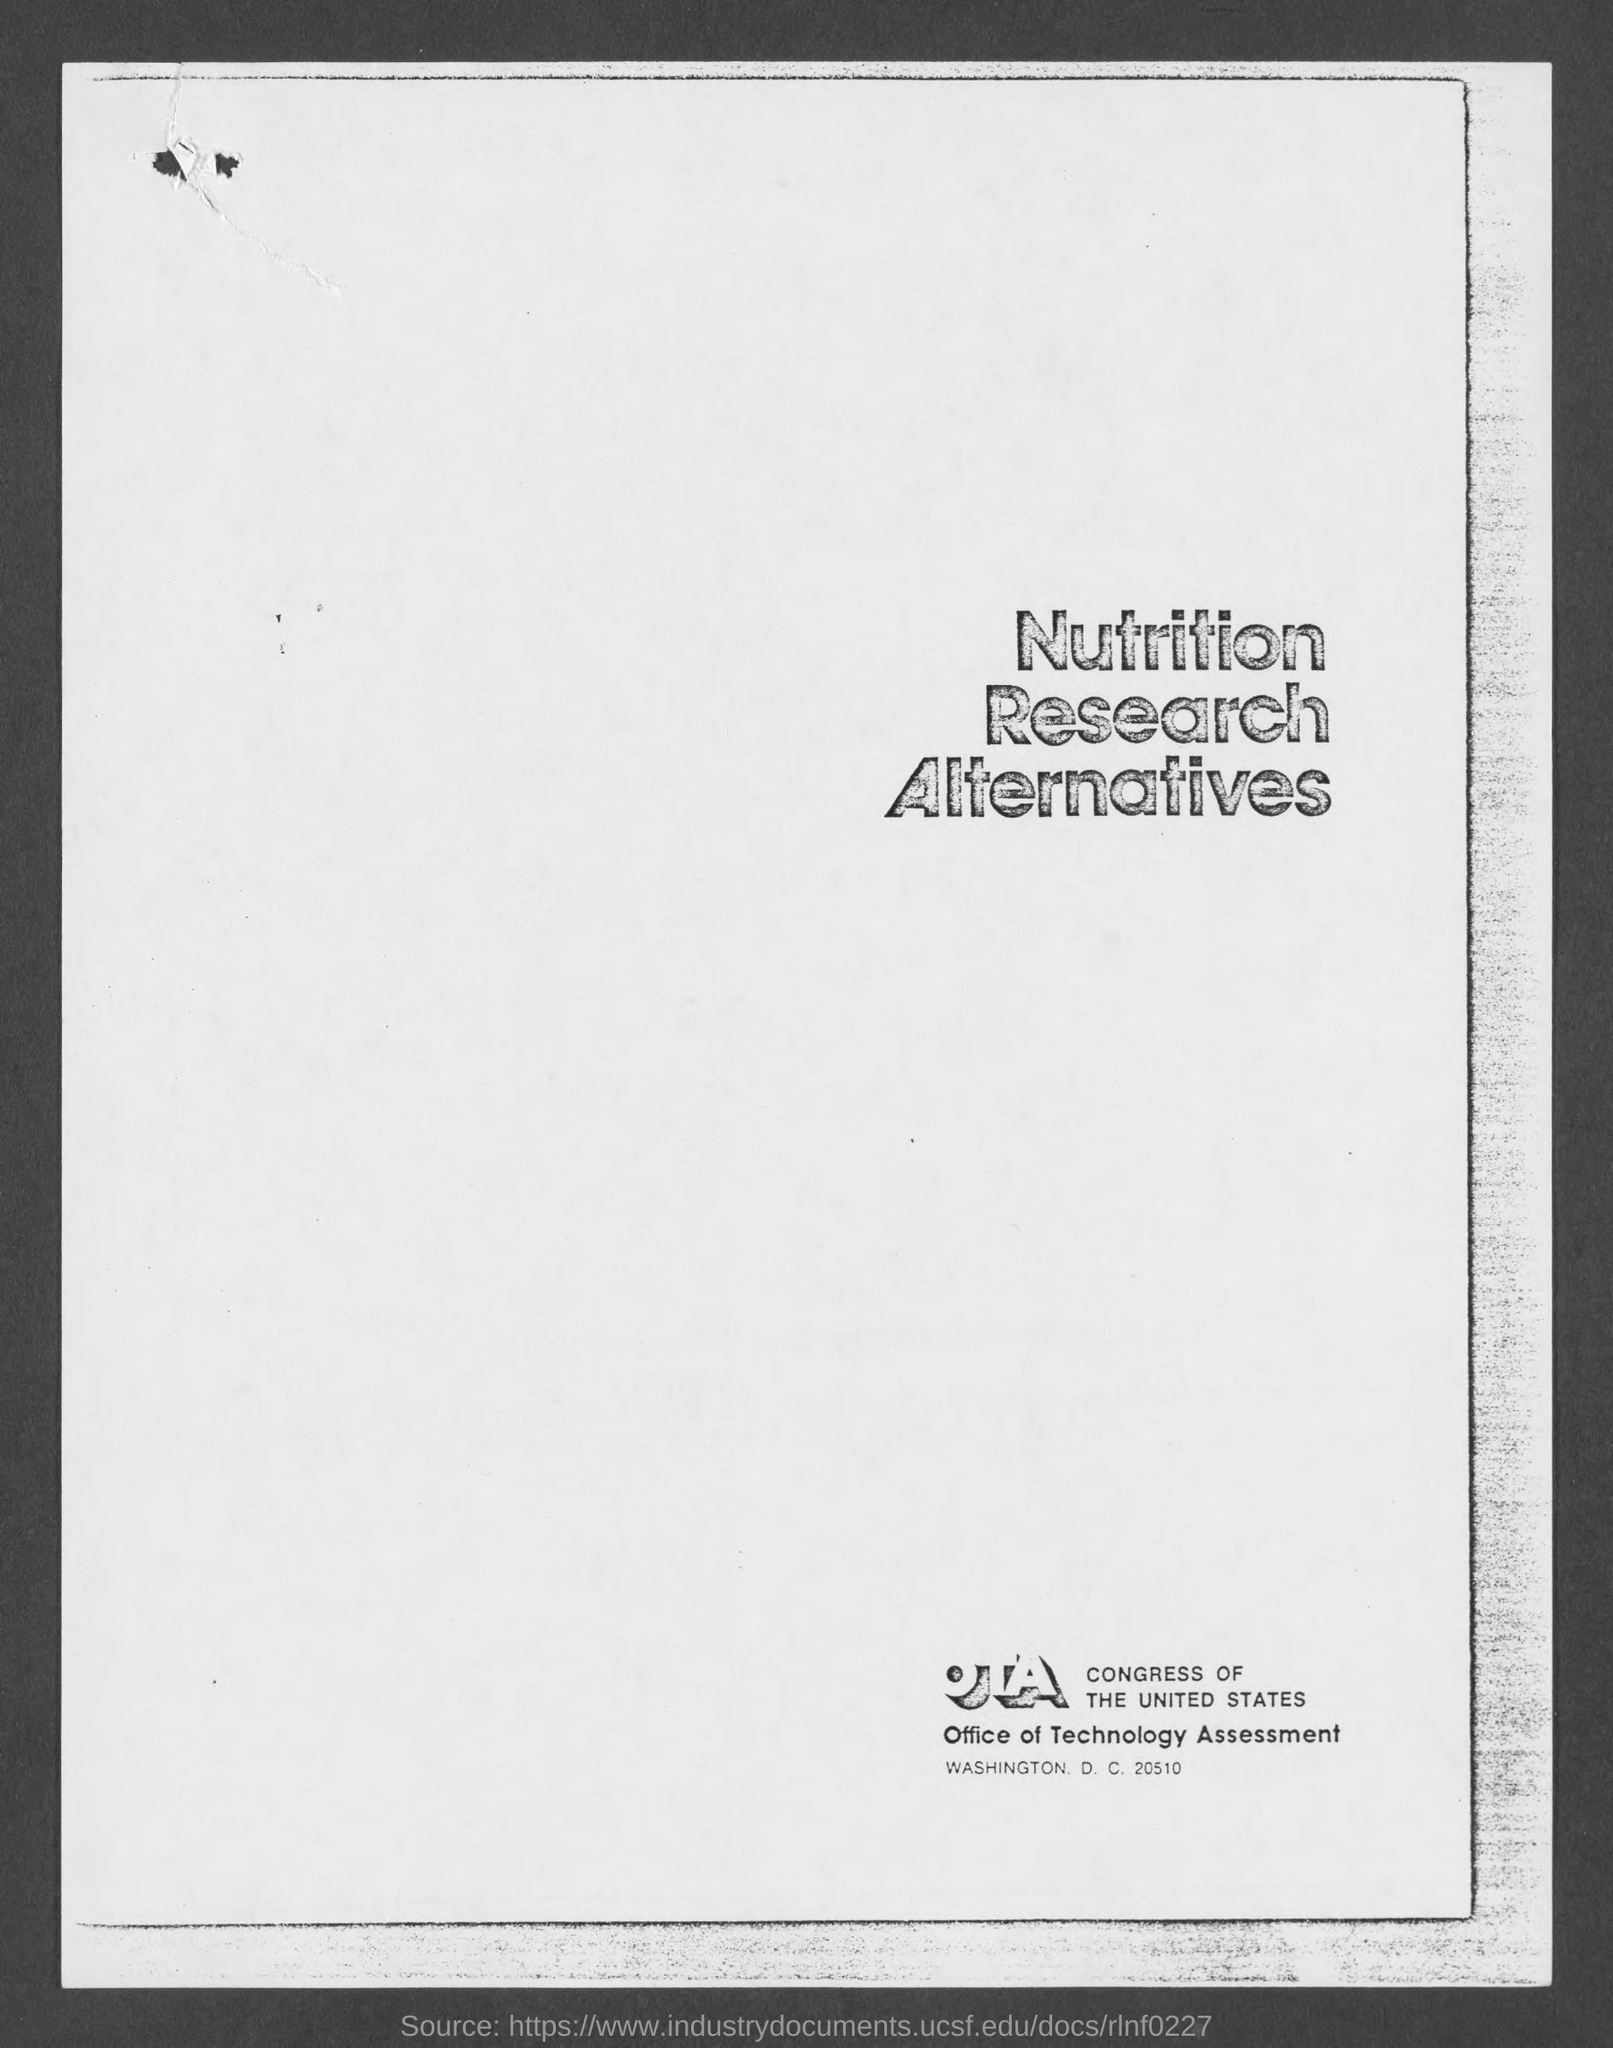Point out several critical features in this image. The title of the document is 'Nutrition Research Alternatives.' The full form of OTA is Office of Technology Assessment. 